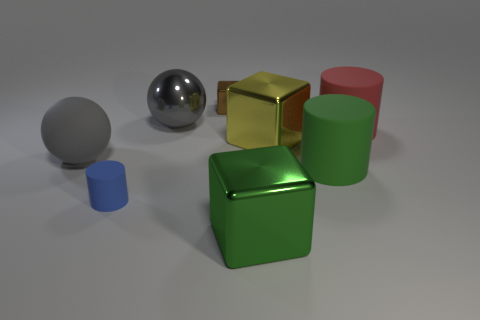There is a object that is the same color as the matte sphere; what is its material?
Your answer should be compact. Metal. There is a matte ball; is it the same color as the sphere right of the blue matte object?
Your answer should be very brief. Yes. There is a matte object that is the same color as the big metallic ball; what is its size?
Ensure brevity in your answer.  Large. Is the large matte sphere the same color as the shiny sphere?
Ensure brevity in your answer.  Yes. Are there fewer red matte things that are on the left side of the large gray metal sphere than cyan cylinders?
Provide a succinct answer. No. What color is the big shiny object left of the green metallic thing?
Give a very brief answer. Gray. What shape is the green metal thing?
Keep it short and to the point. Cube. Is there a shiny block that is in front of the ball left of the cylinder that is to the left of the green rubber object?
Provide a short and direct response. Yes. The large cylinder to the left of the big object that is right of the big green rubber cylinder that is in front of the large rubber ball is what color?
Offer a terse response. Green. There is a blue thing that is the same shape as the large red rubber thing; what material is it?
Ensure brevity in your answer.  Rubber. 